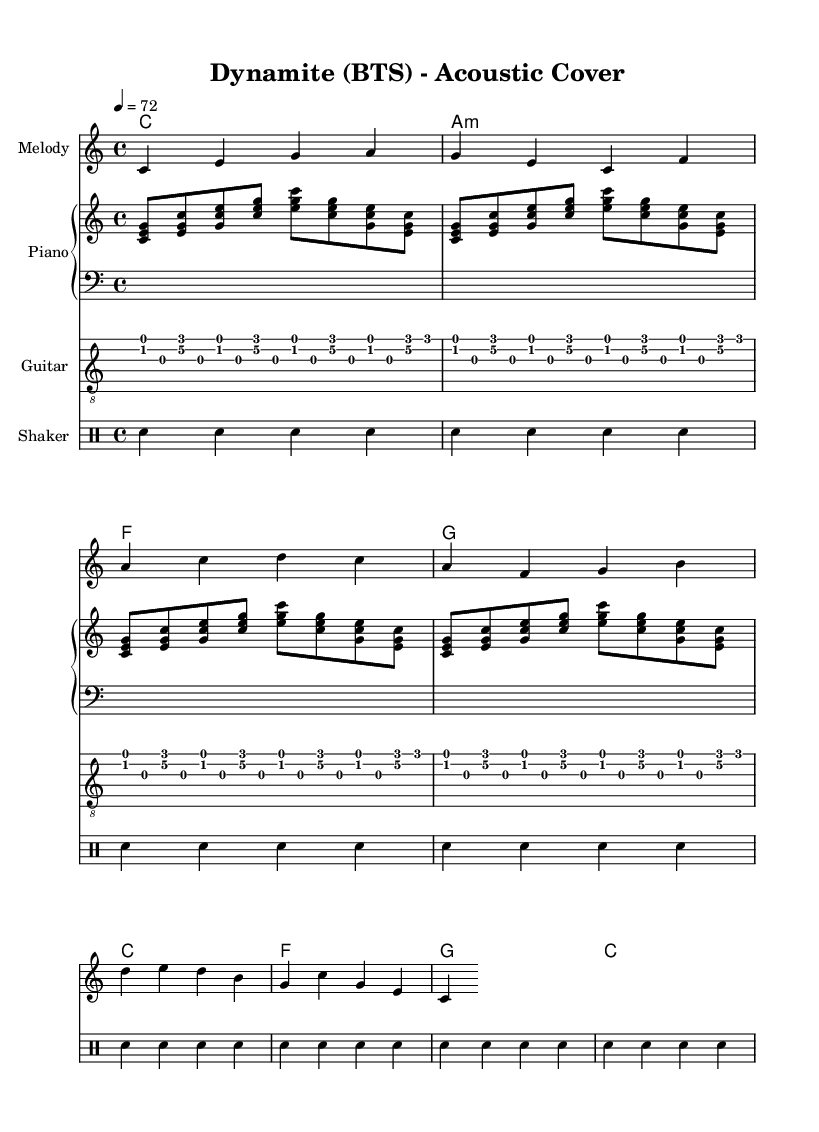What is the key signature of this music? The key signature is C major, which has no sharps or flats, indicated by the absence of any sharp or flat symbols at the beginning of the staff.
Answer: C major What is the time signature of this music? The time signature is 4/4, which is shown at the beginning of the score, indicating four beats per measure and the quarter note gets one beat.
Answer: 4/4 What is the tempo of this music? The tempo is 72 beats per minute, indicated by the mark "4 = 72", which specifies the speed at which the piece should be played.
Answer: 72 How many measures are in the melody section? The melody has a total of 4 measures, as counted by the vertical bar lines separating each measure in the notation.
Answer: 4 Which instrument plays the harmony? The harmony is played by the ChordNames, which is commonly associated with keyboard instruments, specifically the piano in this score.
Answer: Piano What is the rhythmic pattern used for the shaker? The shaker uses a pattern of steady quarter notes, as indicated in the drummode where snare hits are repeated in a continuous sequence.
Answer: Quarter notes Is this sheet music for a cover of a K-Pop song? Yes, the title indicates that it is an acoustic cover of "Dynamite" by BTS, a popular K-Pop group, making it clear that the arrangement is in the K-Pop style.
Answer: Yes 